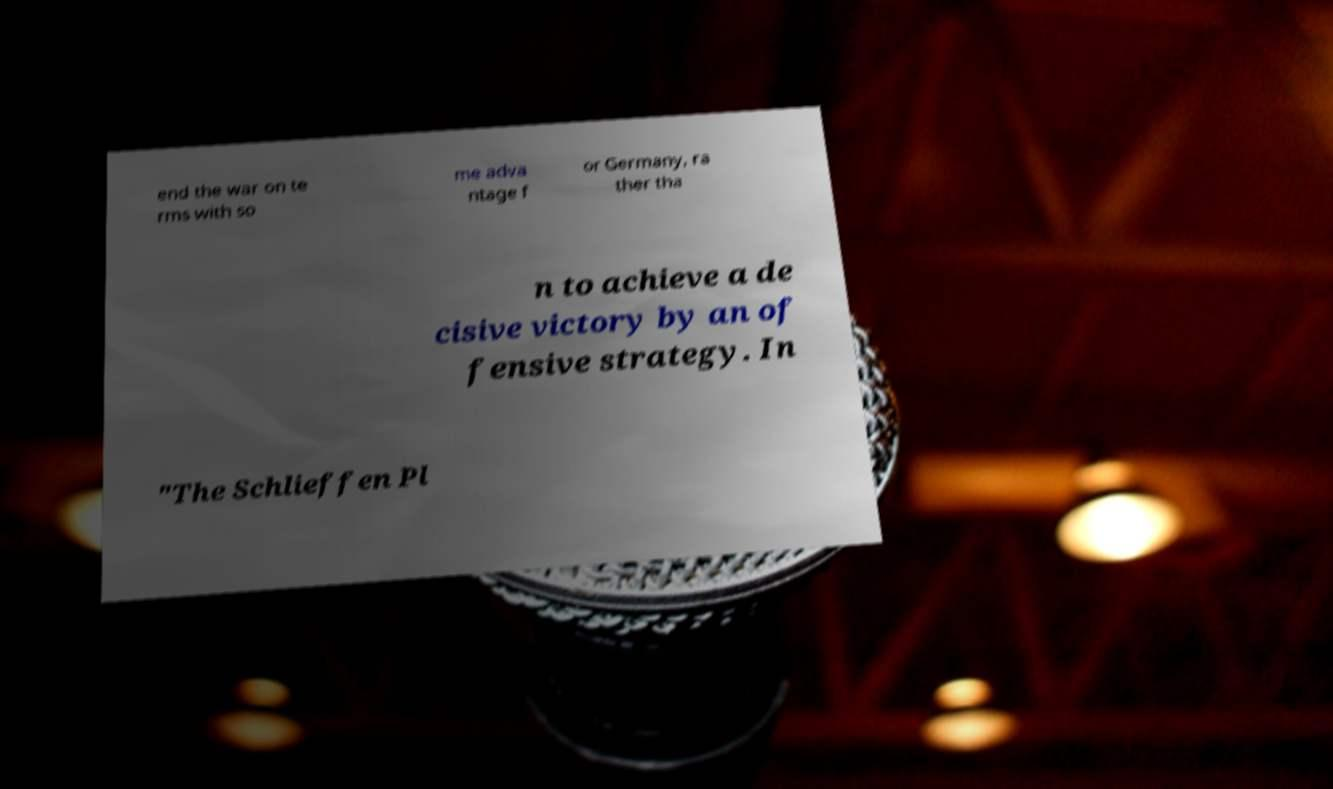Could you assist in decoding the text presented in this image and type it out clearly? end the war on te rms with so me adva ntage f or Germany, ra ther tha n to achieve a de cisive victory by an of fensive strategy. In "The Schlieffen Pl 